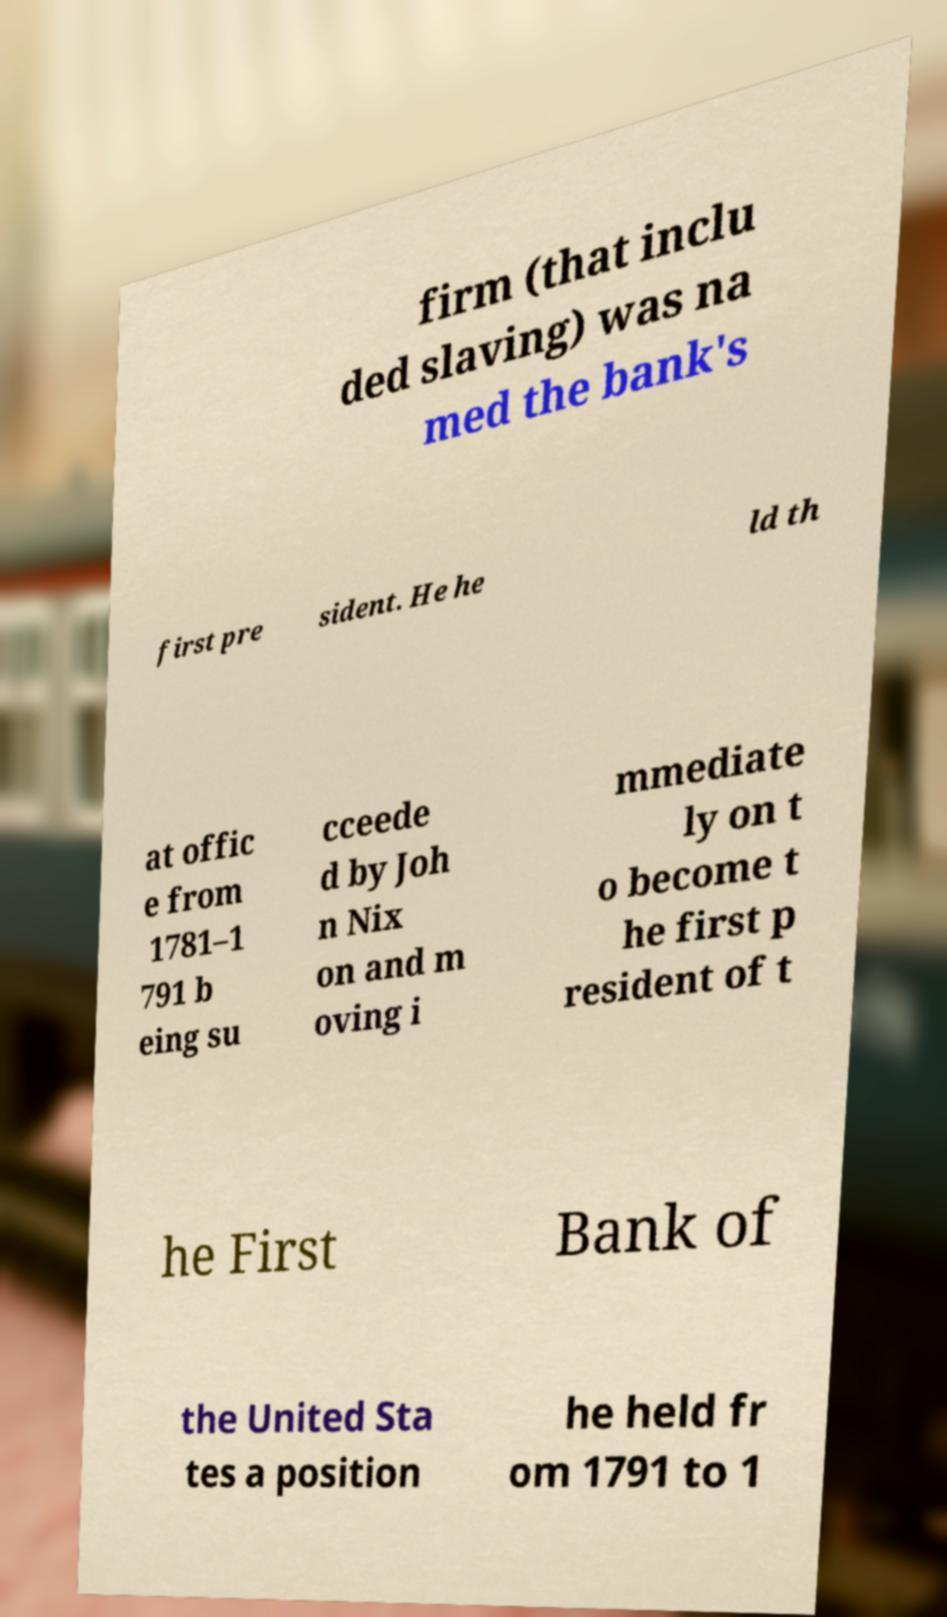There's text embedded in this image that I need extracted. Can you transcribe it verbatim? firm (that inclu ded slaving) was na med the bank's first pre sident. He he ld th at offic e from 1781–1 791 b eing su cceede d by Joh n Nix on and m oving i mmediate ly on t o become t he first p resident of t he First Bank of the United Sta tes a position he held fr om 1791 to 1 